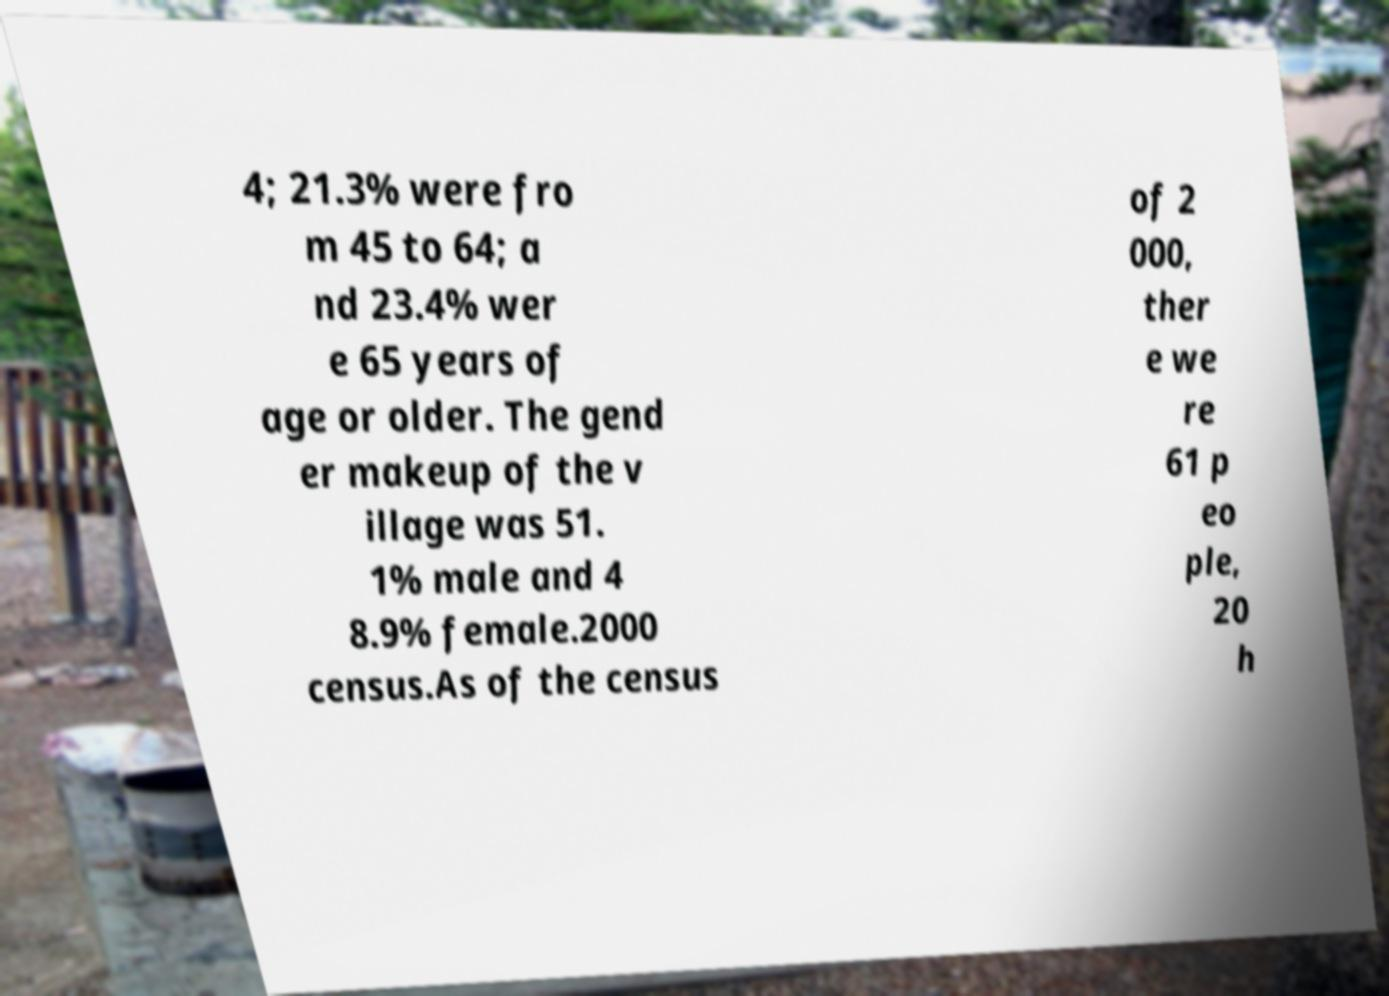For documentation purposes, I need the text within this image transcribed. Could you provide that? 4; 21.3% were fro m 45 to 64; a nd 23.4% wer e 65 years of age or older. The gend er makeup of the v illage was 51. 1% male and 4 8.9% female.2000 census.As of the census of 2 000, ther e we re 61 p eo ple, 20 h 